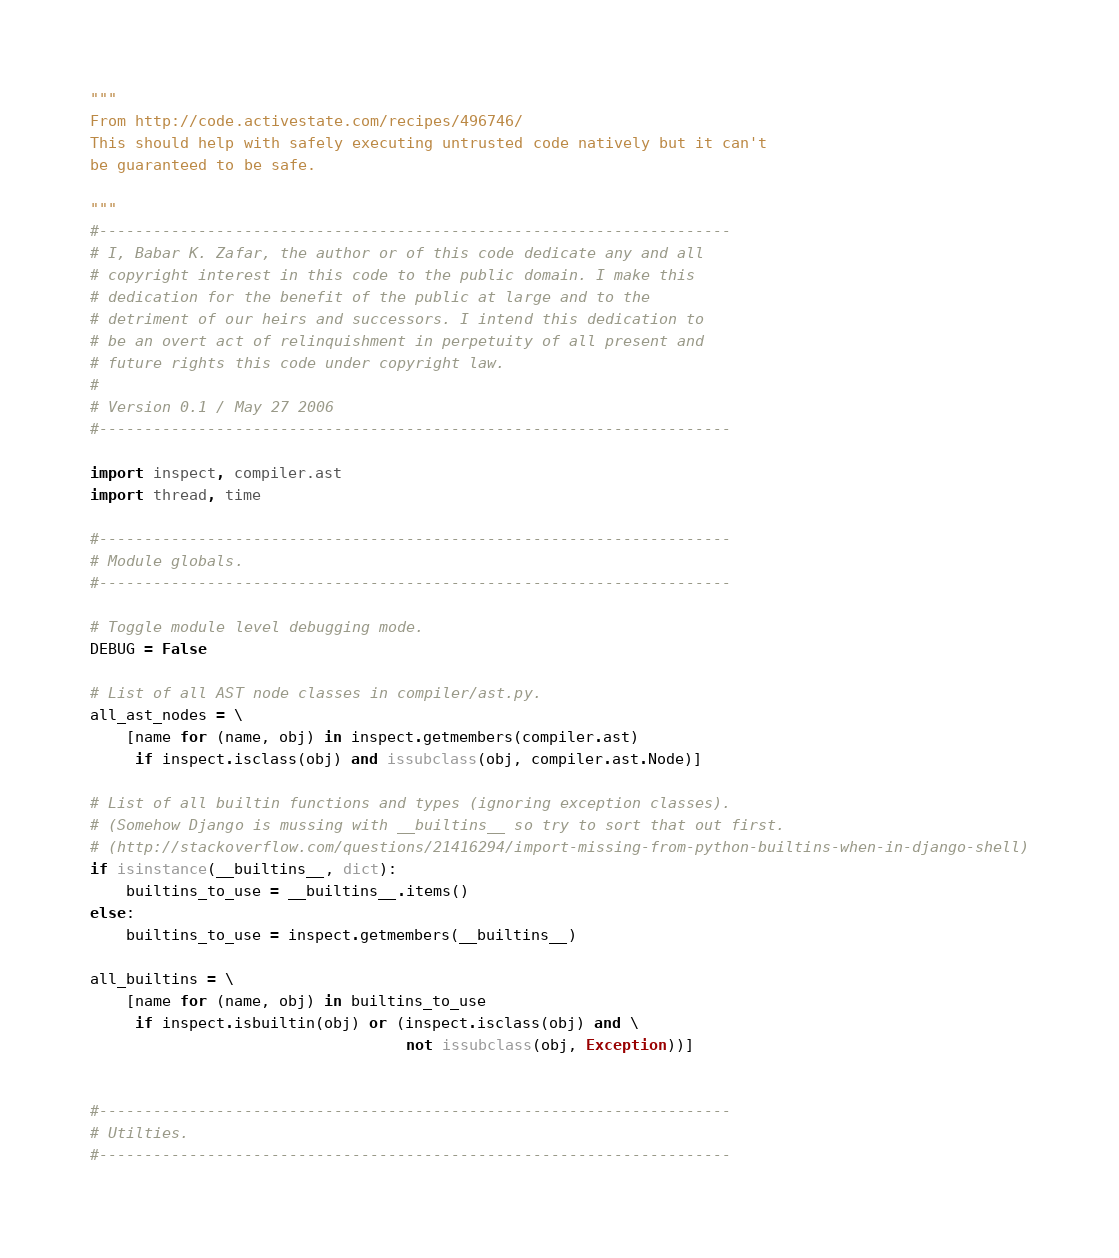<code> <loc_0><loc_0><loc_500><loc_500><_Python_>
"""
From http://code.activestate.com/recipes/496746/
This should help with safely executing untrusted code natively but it can't
be guaranteed to be safe.

"""
#----------------------------------------------------------------------
# I, Babar K. Zafar, the author or of this code dedicate any and all
# copyright interest in this code to the public domain. I make this
# dedication for the benefit of the public at large and to the
# detriment of our heirs and successors. I intend this dedication to
# be an overt act of relinquishment in perpetuity of all present and
# future rights this code under copyright law.
#
# Version 0.1 / May 27 2006
#----------------------------------------------------------------------

import inspect, compiler.ast
import thread, time

#----------------------------------------------------------------------
# Module globals.
#----------------------------------------------------------------------

# Toggle module level debugging mode.
DEBUG = False

# List of all AST node classes in compiler/ast.py.
all_ast_nodes = \
    [name for (name, obj) in inspect.getmembers(compiler.ast)
     if inspect.isclass(obj) and issubclass(obj, compiler.ast.Node)]

# List of all builtin functions and types (ignoring exception classes).
# (Somehow Django is mussing with __builtins__ so try to sort that out first.
# (http://stackoverflow.com/questions/21416294/import-missing-from-python-builtins-when-in-django-shell)
if isinstance(__builtins__, dict):
    builtins_to_use = __builtins__.items()
else:
    builtins_to_use = inspect.getmembers(__builtins__)

all_builtins = \
    [name for (name, obj) in builtins_to_use
     if inspect.isbuiltin(obj) or (inspect.isclass(obj) and \
                                   not issubclass(obj, Exception))]


#----------------------------------------------------------------------
# Utilties.
#----------------------------------------------------------------------
</code> 